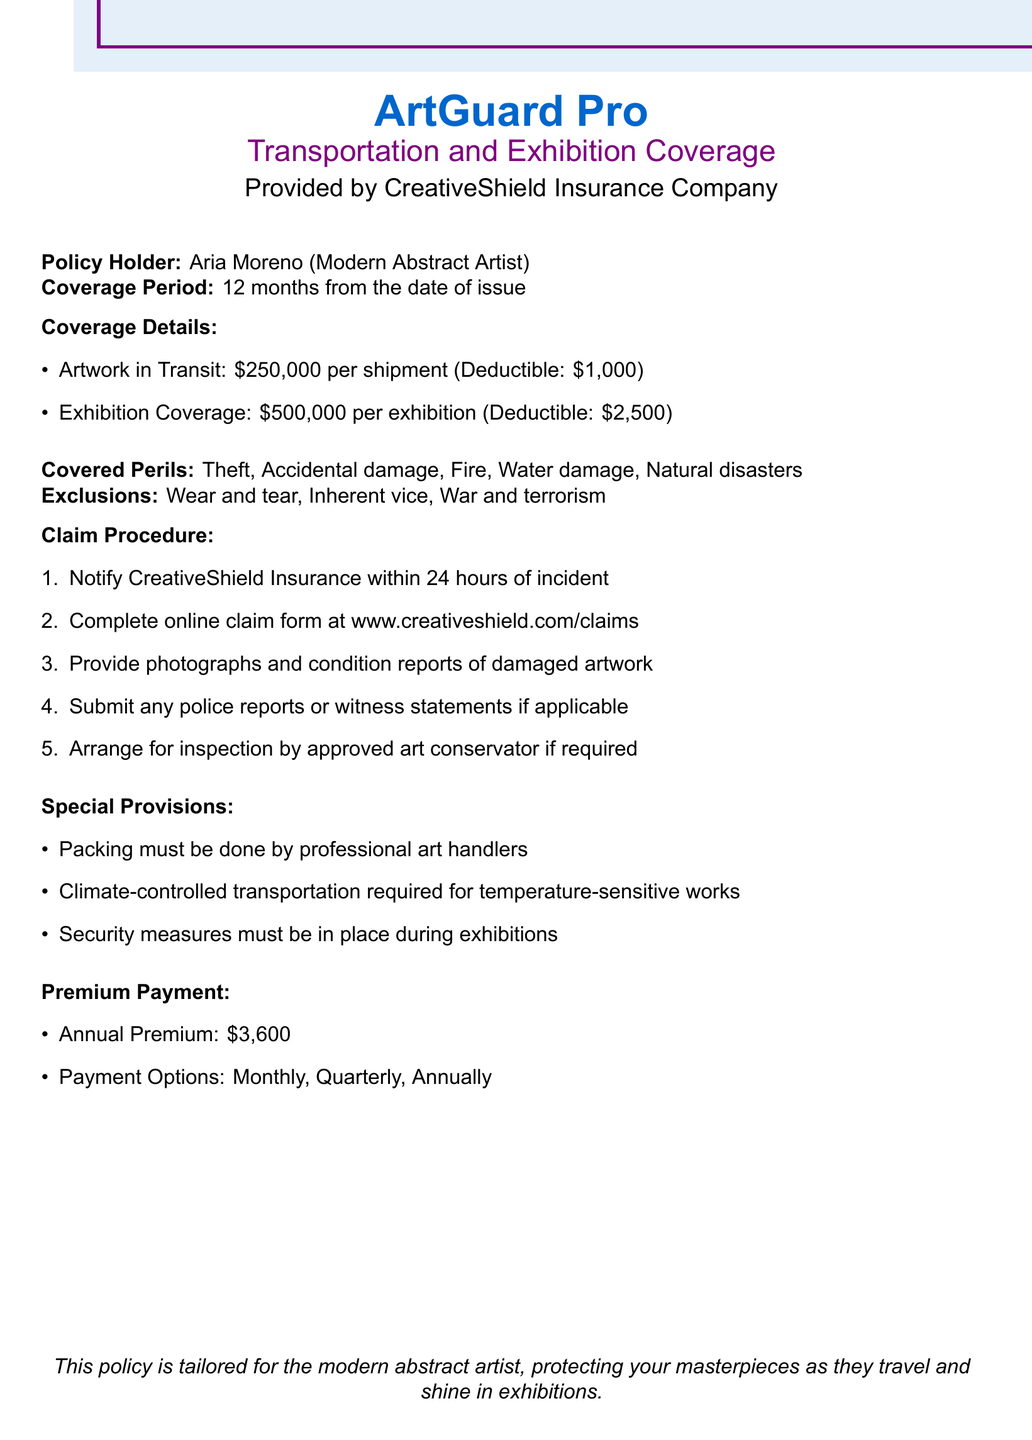What is the coverage limit for artwork in transit? The coverage limit for artwork in transit is specified in the document.
Answer: $250,000 What is the deductible for exhibition coverage? The deductible for exhibition coverage can be found in the coverage details of the document.
Answer: $2,500 What should be provided along with the claim form? The claim procedure lists requirements, including additional documents needed for the claim.
Answer: Photographs and condition reports What are excluded perils under this policy? The document outlines specific exclusions that apply to this policy regarding coverage.
Answer: Wear and tear, Inherent vice, War and terrorism What is the annual premium amount? The premium payment section lists the annual premium amount required for the insurance policy.
Answer: $3,600 How long does the policy coverage last? The document specifies the duration of the coverage period directly.
Answer: 12 months What are the special provisions for packing? Special provisions are detailed in the relevant section of the document concerning packing.
Answer: Professional art handlers Which insurance company provides this policy? The document indicates the name of the insurance company offering this policy.
Answer: CreativeShield Insurance Company How soon must CreativeShield Insurance be notified after an incident? The claim procedure explicitly states the notification timeframe after an incident.
Answer: 24 hours 